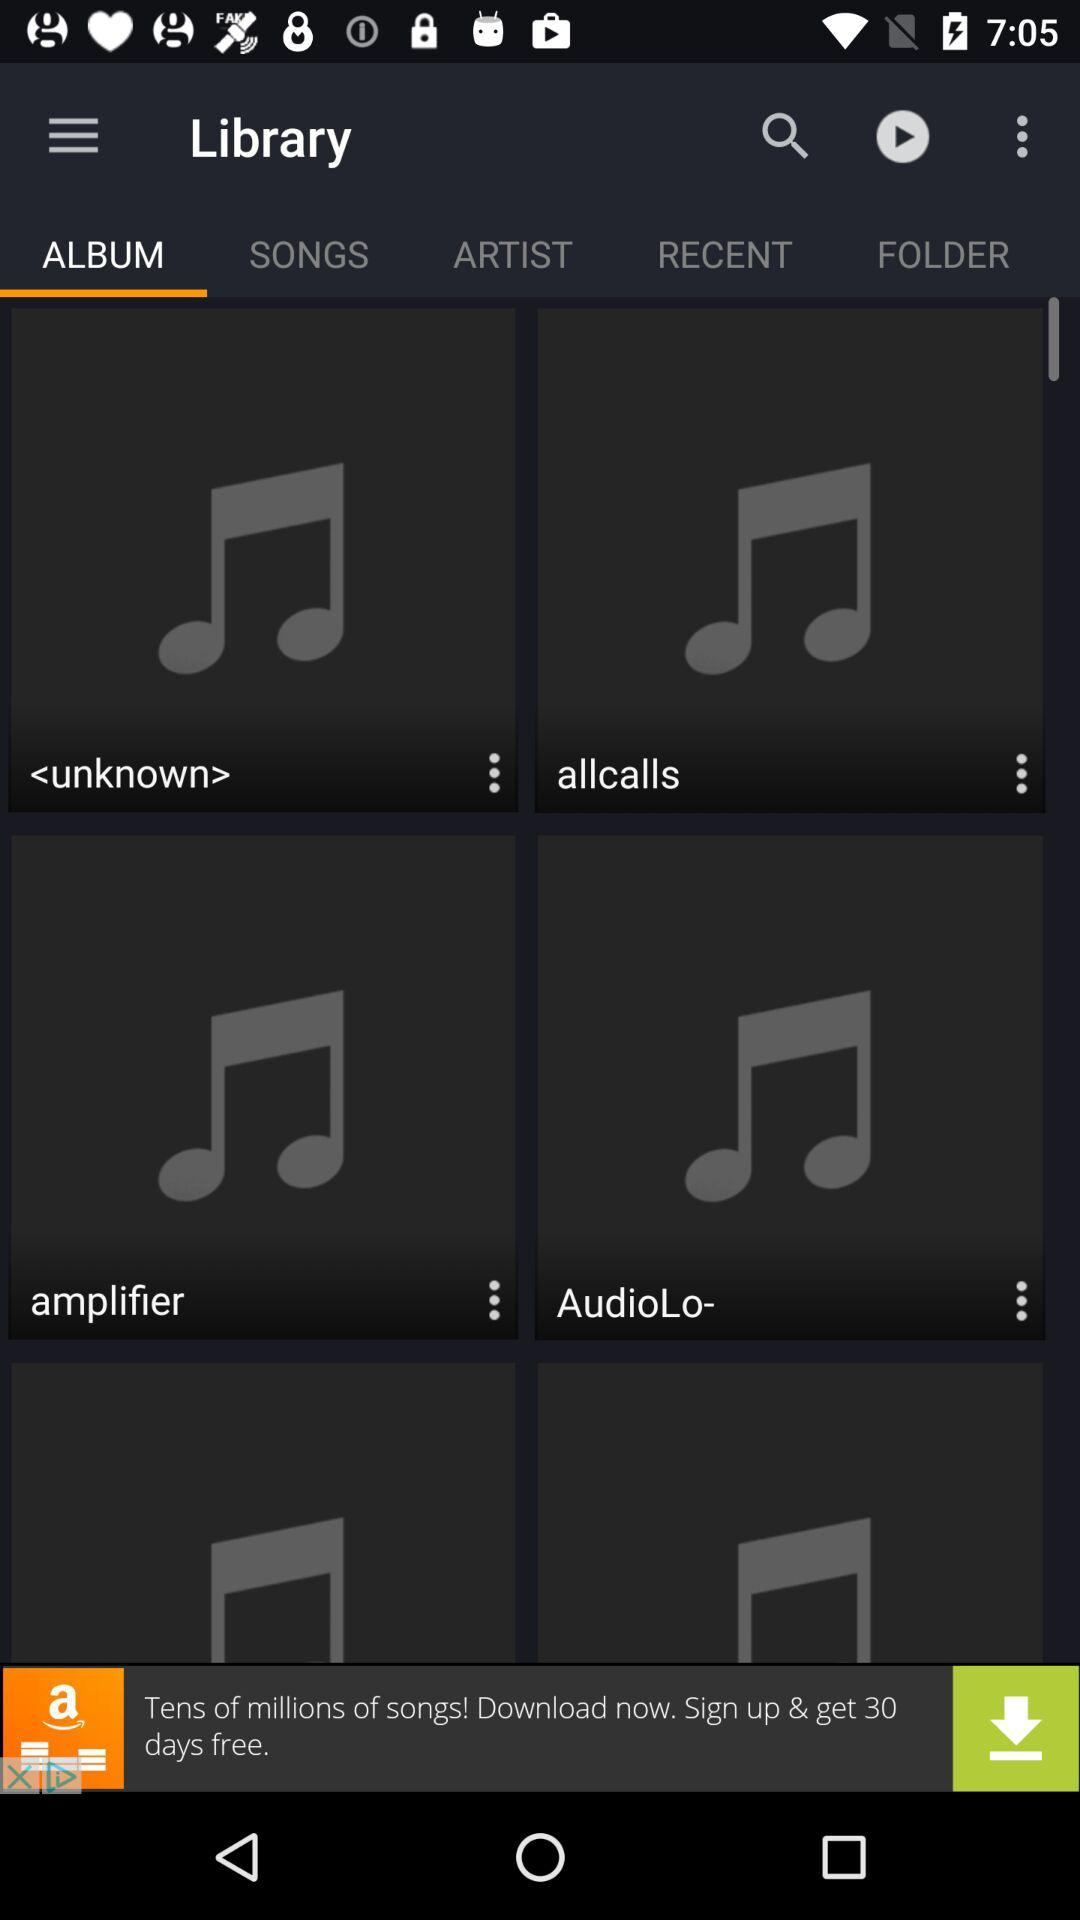Which tab is selected? The selected tab is "ALBUM". 